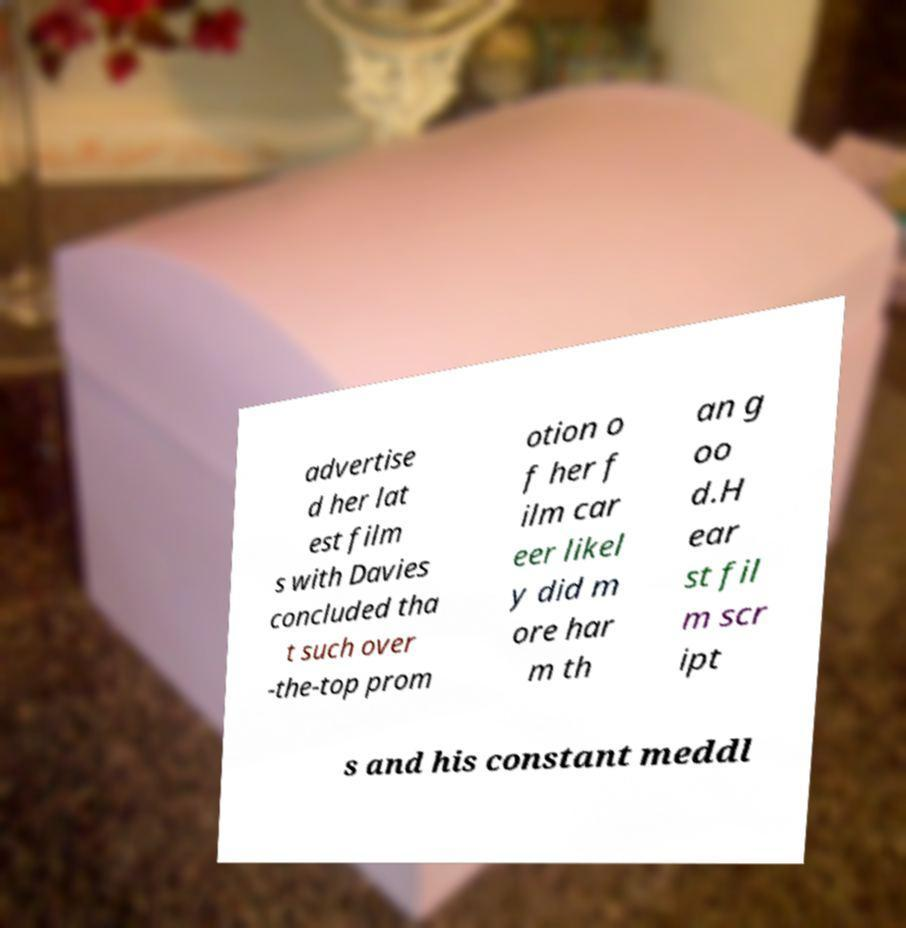What messages or text are displayed in this image? I need them in a readable, typed format. advertise d her lat est film s with Davies concluded tha t such over -the-top prom otion o f her f ilm car eer likel y did m ore har m th an g oo d.H ear st fil m scr ipt s and his constant meddl 